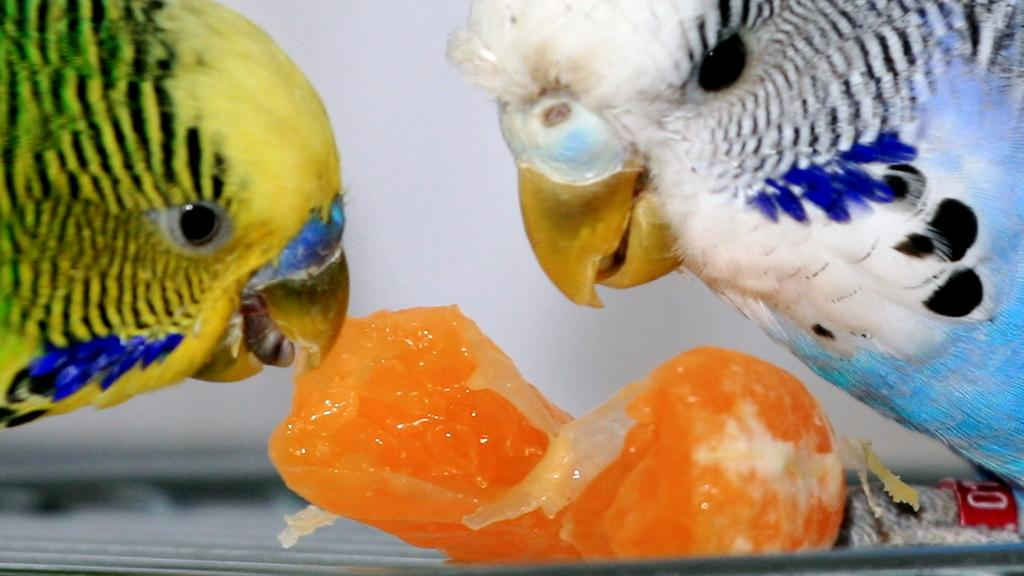What animals are in the foreground of the image? There are two parrots in the foreground of the image. What is one of the parrots doing in the image? One of the parrots is eating a piece of an orange. What type of food is the parrot eating? The parrot is eating a piece of an orange. Can you see a boat in the image? There is no boat present in the image. How many wings does the kitty have in the image? There is no kitty present in the image, so it is not possible to determine the number of wings it might have. 